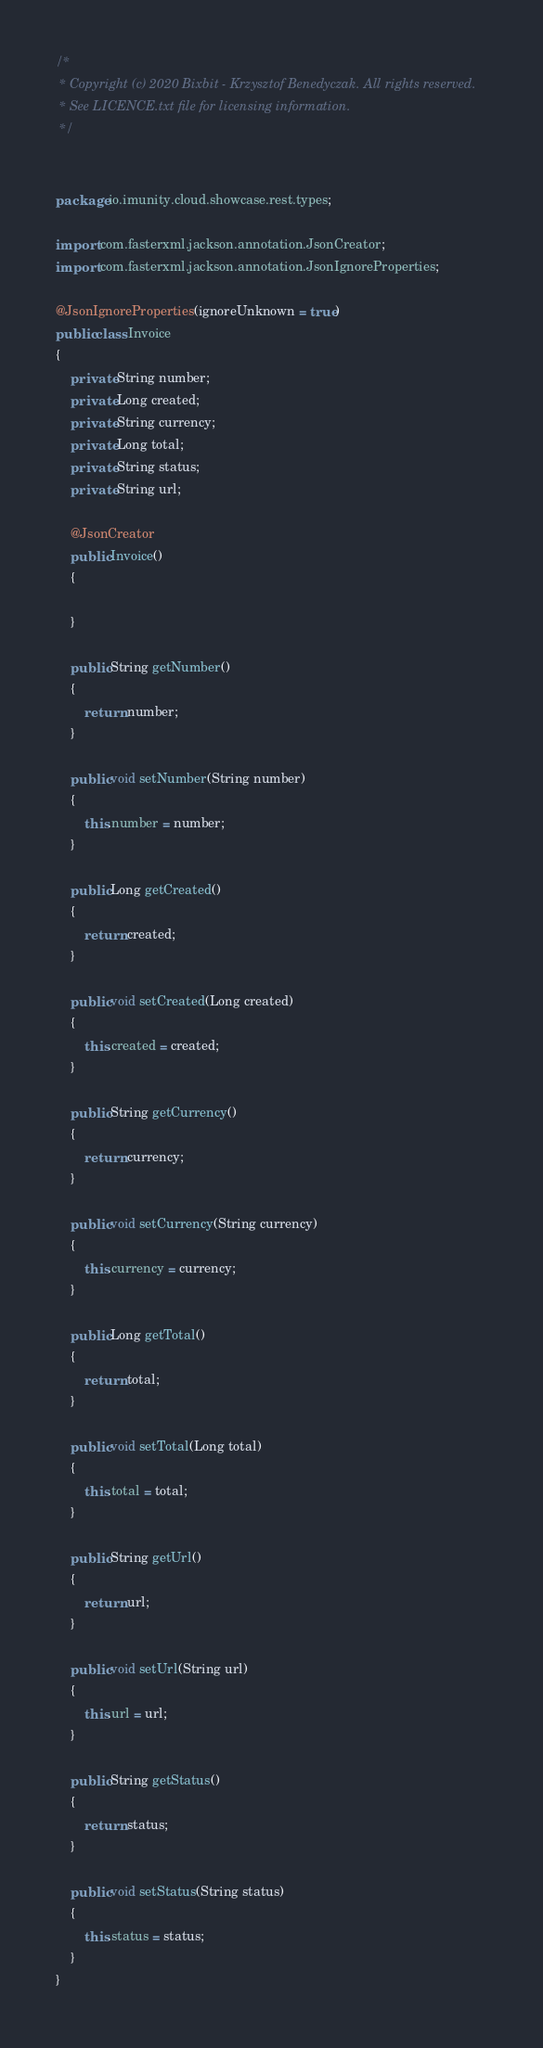<code> <loc_0><loc_0><loc_500><loc_500><_Java_>/*
 * Copyright (c) 2020 Bixbit - Krzysztof Benedyczak. All rights reserved.
 * See LICENCE.txt file for licensing information.
 */


package io.imunity.cloud.showcase.rest.types;

import com.fasterxml.jackson.annotation.JsonCreator;
import com.fasterxml.jackson.annotation.JsonIgnoreProperties;

@JsonIgnoreProperties(ignoreUnknown = true)
public class Invoice
{
	private String number;
	private Long created;
	private String currency;
	private Long total;
	private String status;
	private String url;

	@JsonCreator
	public Invoice()
	{

	}

	public String getNumber()
	{
		return number;
	}

	public void setNumber(String number)
	{
		this.number = number;
	}

	public Long getCreated()
	{
		return created;
	}

	public void setCreated(Long created)
	{
		this.created = created;
	}

	public String getCurrency()
	{
		return currency;
	}

	public void setCurrency(String currency)
	{
		this.currency = currency;
	}

	public Long getTotal()
	{
		return total;
	}

	public void setTotal(Long total)
	{
		this.total = total;
	}

	public String getUrl()
	{
		return url;
	}

	public void setUrl(String url)
	{
		this.url = url;
	}

	public String getStatus()
	{
		return status;
	}

	public void setStatus(String status)
	{
		this.status = status;
	}
}</code> 